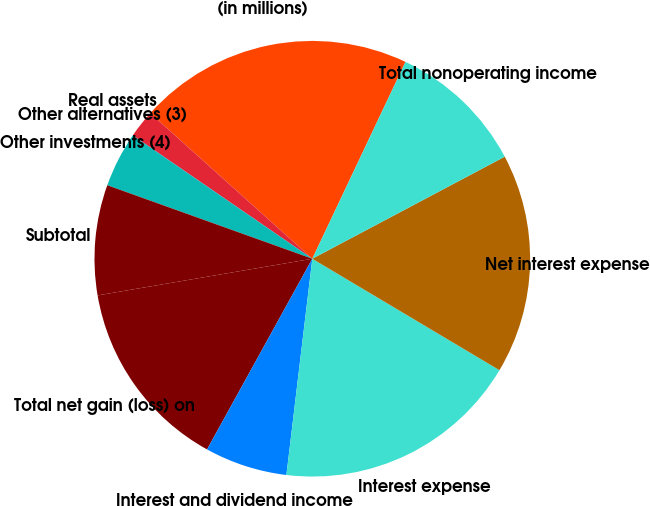<chart> <loc_0><loc_0><loc_500><loc_500><pie_chart><fcel>(in millions)<fcel>Real assets<fcel>Other alternatives (3)<fcel>Other investments (4)<fcel>Subtotal<fcel>Total net gain (loss) on<fcel>Interest and dividend income<fcel>Interest expense<fcel>Net interest expense<fcel>Total nonoperating income<nl><fcel>20.39%<fcel>2.06%<fcel>0.02%<fcel>4.09%<fcel>8.17%<fcel>14.28%<fcel>6.13%<fcel>18.35%<fcel>16.31%<fcel>10.2%<nl></chart> 